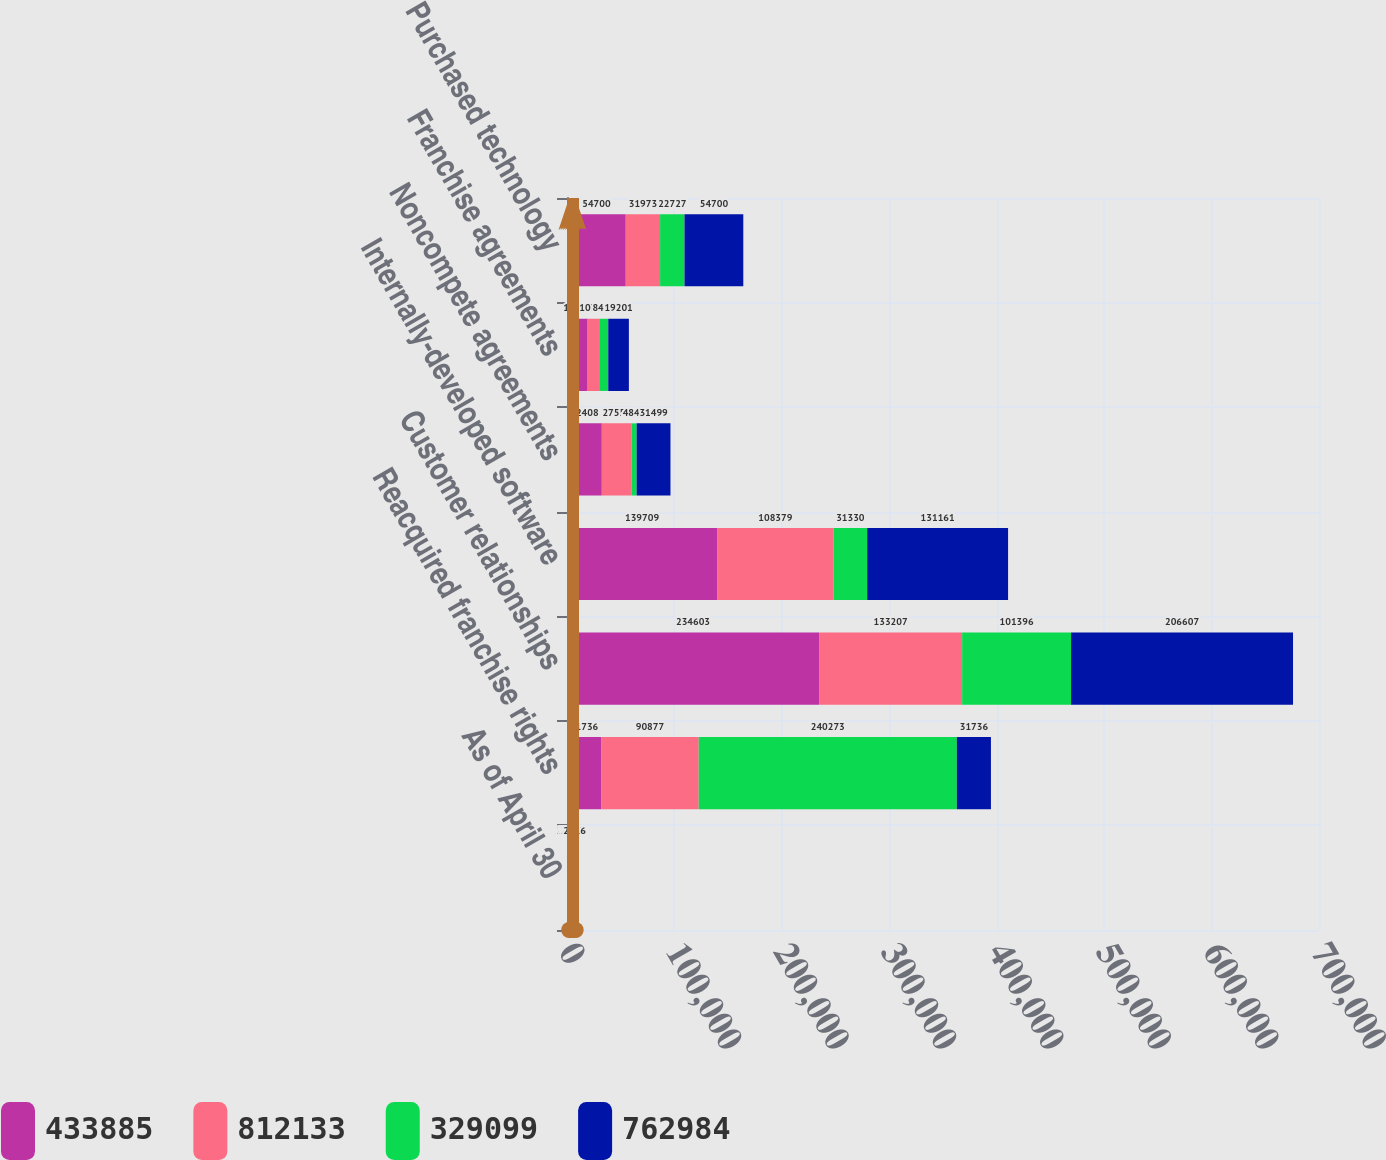Convert chart. <chart><loc_0><loc_0><loc_500><loc_500><stacked_bar_chart><ecel><fcel>As of April 30<fcel>Reacquired franchise rights<fcel>Customer relationships<fcel>Internally-developed software<fcel>Noncompete agreements<fcel>Franchise agreements<fcel>Purchased technology<nl><fcel>433885<fcel>2017<fcel>31736<fcel>234603<fcel>139709<fcel>32408<fcel>19201<fcel>54700<nl><fcel>812133<fcel>2017<fcel>90877<fcel>133207<fcel>108379<fcel>27559<fcel>10774<fcel>31973<nl><fcel>329099<fcel>2017<fcel>240273<fcel>101396<fcel>31330<fcel>4849<fcel>8427<fcel>22727<nl><fcel>762984<fcel>2016<fcel>31736<fcel>206607<fcel>131161<fcel>31499<fcel>19201<fcel>54700<nl></chart> 